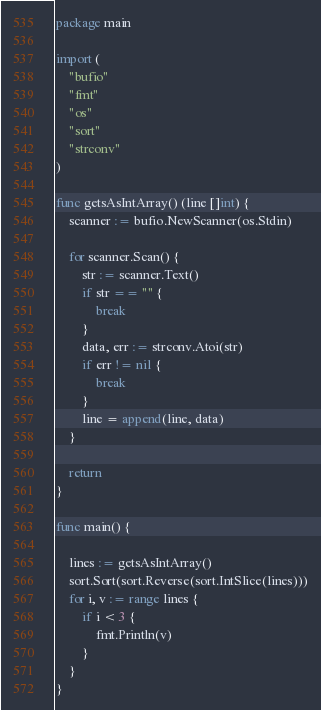Convert code to text. <code><loc_0><loc_0><loc_500><loc_500><_Go_>package main

import (
	"bufio"
	"fmt"
	"os"
	"sort"
	"strconv"
)

func getsAsIntArray() (line []int) {
	scanner := bufio.NewScanner(os.Stdin)

	for scanner.Scan() {
		str := scanner.Text()
		if str == "" {
			break
		}
		data, err := strconv.Atoi(str)
		if err != nil {
			break
		}
		line = append(line, data)
	}

	return
}

func main() {

	lines := getsAsIntArray()
	sort.Sort(sort.Reverse(sort.IntSlice(lines)))
	for i, v := range lines {
		if i < 3 {
			fmt.Println(v)
		}
	}
}

</code> 